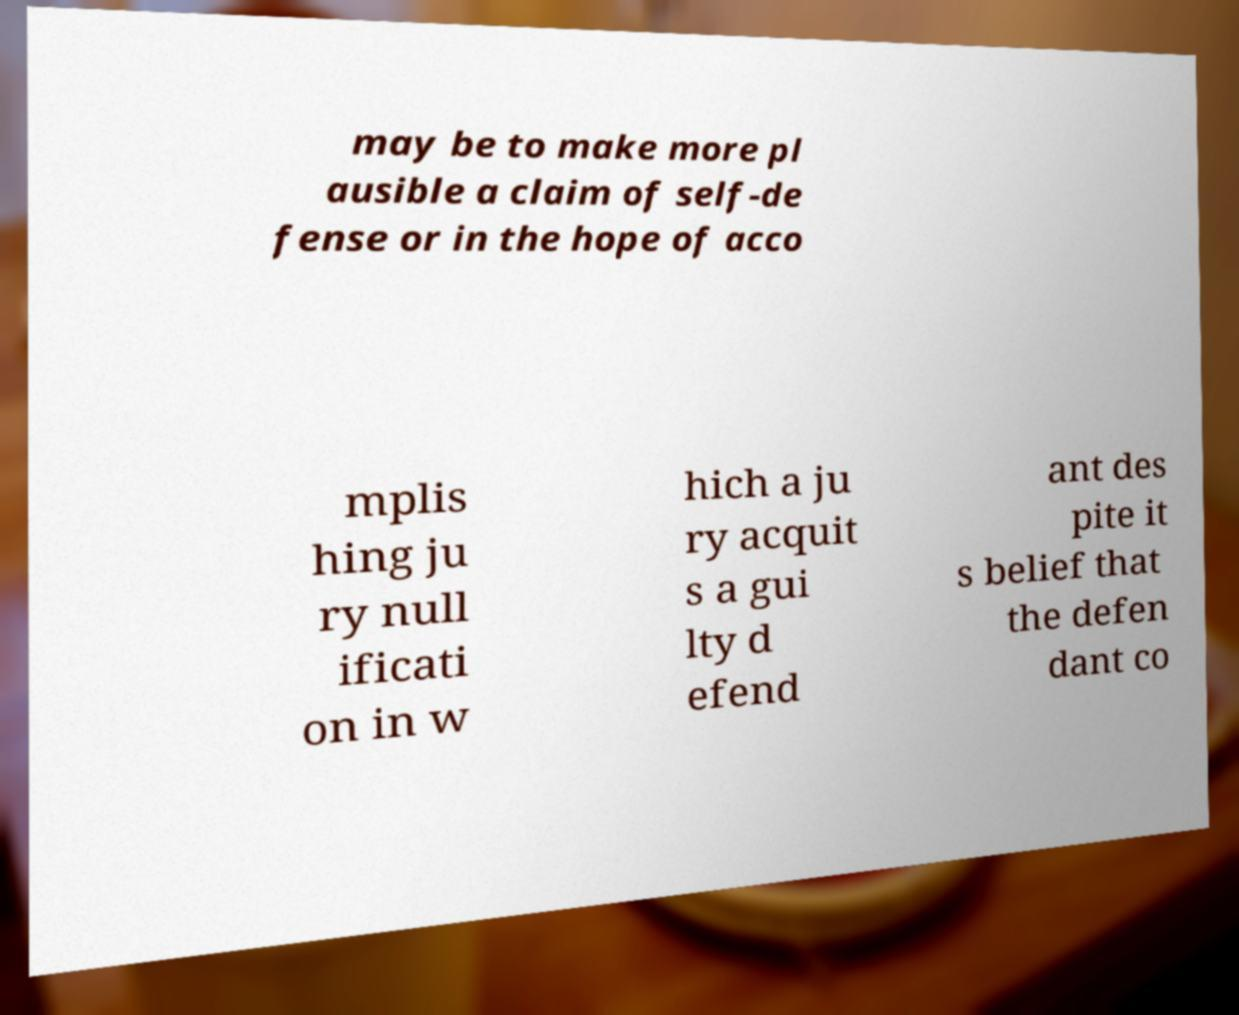Could you extract and type out the text from this image? may be to make more pl ausible a claim of self-de fense or in the hope of acco mplis hing ju ry null ificati on in w hich a ju ry acquit s a gui lty d efend ant des pite it s belief that the defen dant co 